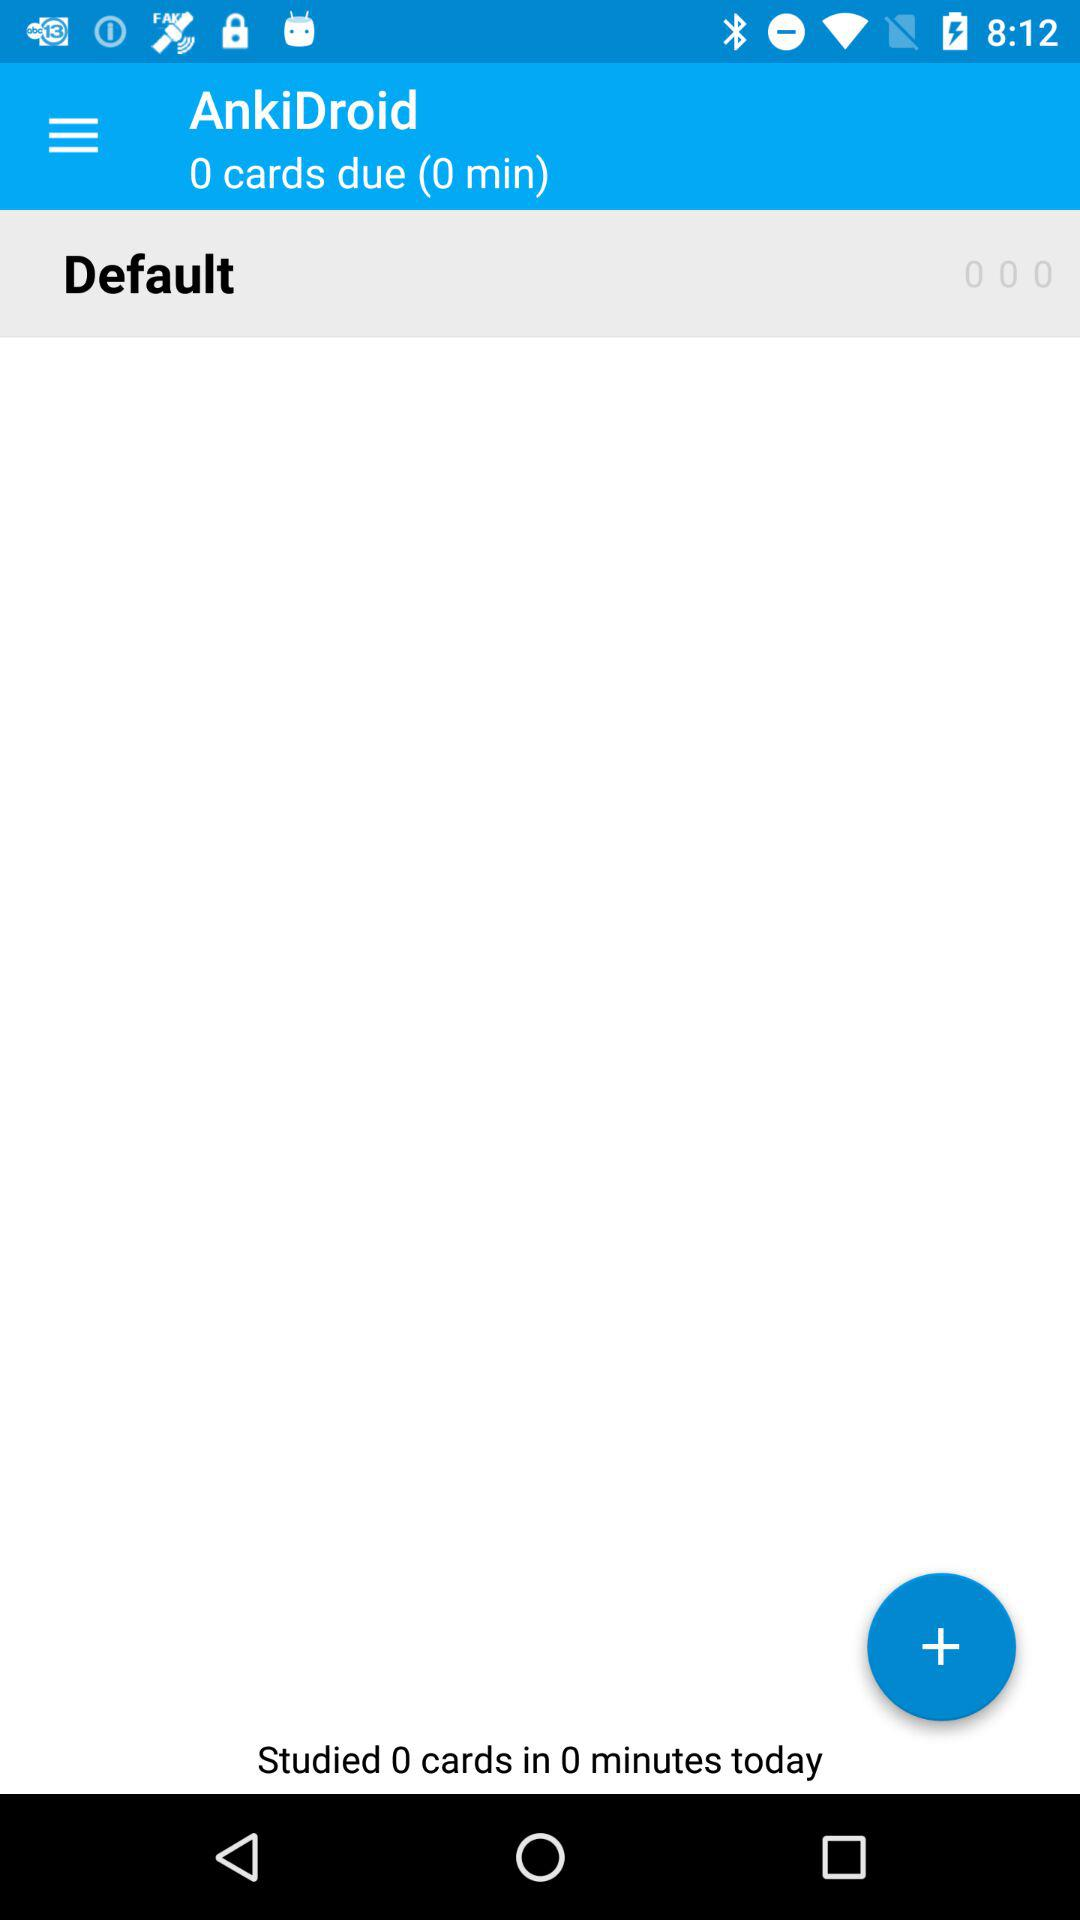What is the number of due cards? The number is 0. 